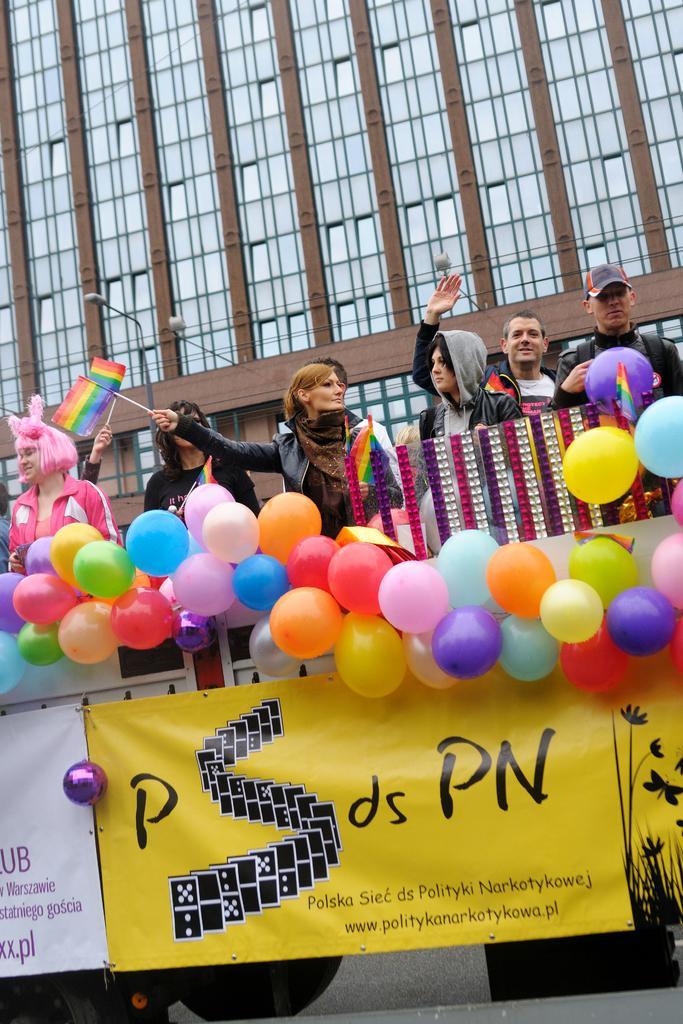Could you give a brief overview of what you see in this image? In this image I can see few boards and number of balloons in the front. On these words I can see something is written. In the background I can see few people are standing and few of them are holding flags. I can also see a building and few lights in the background. 